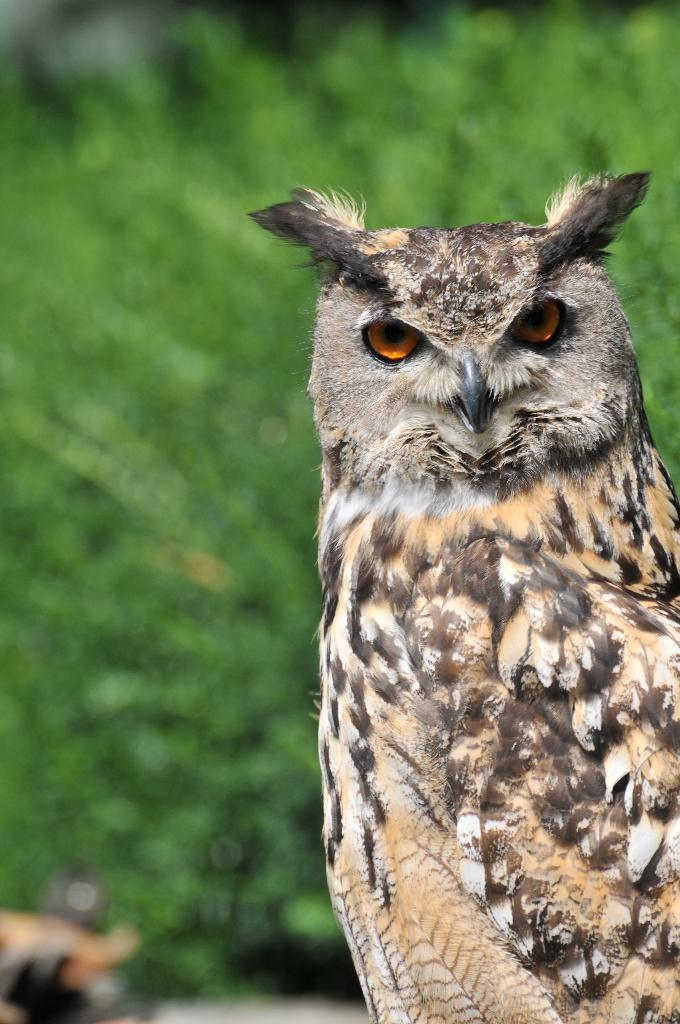What animal is the main subject of the picture? There is an owl in the picture. What can be seen in the background of the picture? There are plants visible in the background of the picture. What type of development can be seen in the picture? There is no development visible in the picture; it features an owl and plants in the background. Can you see a bear in the picture? No, there is no bear present in the picture. 